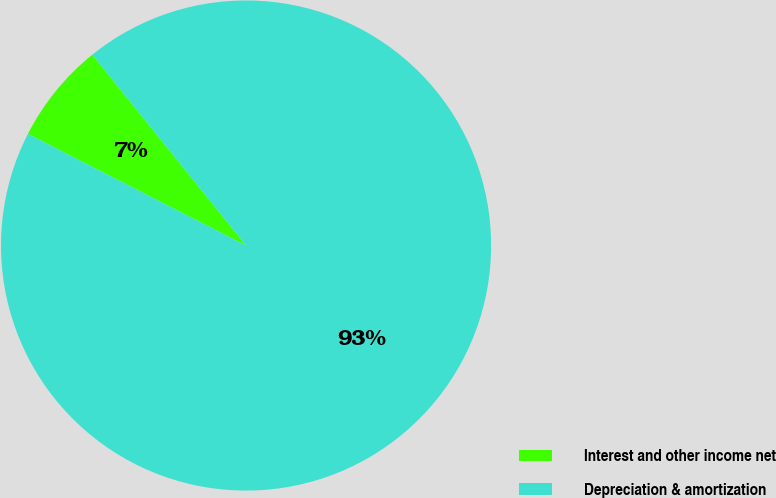<chart> <loc_0><loc_0><loc_500><loc_500><pie_chart><fcel>Interest and other income net<fcel>Depreciation & amortization<nl><fcel>6.68%<fcel>93.32%<nl></chart> 